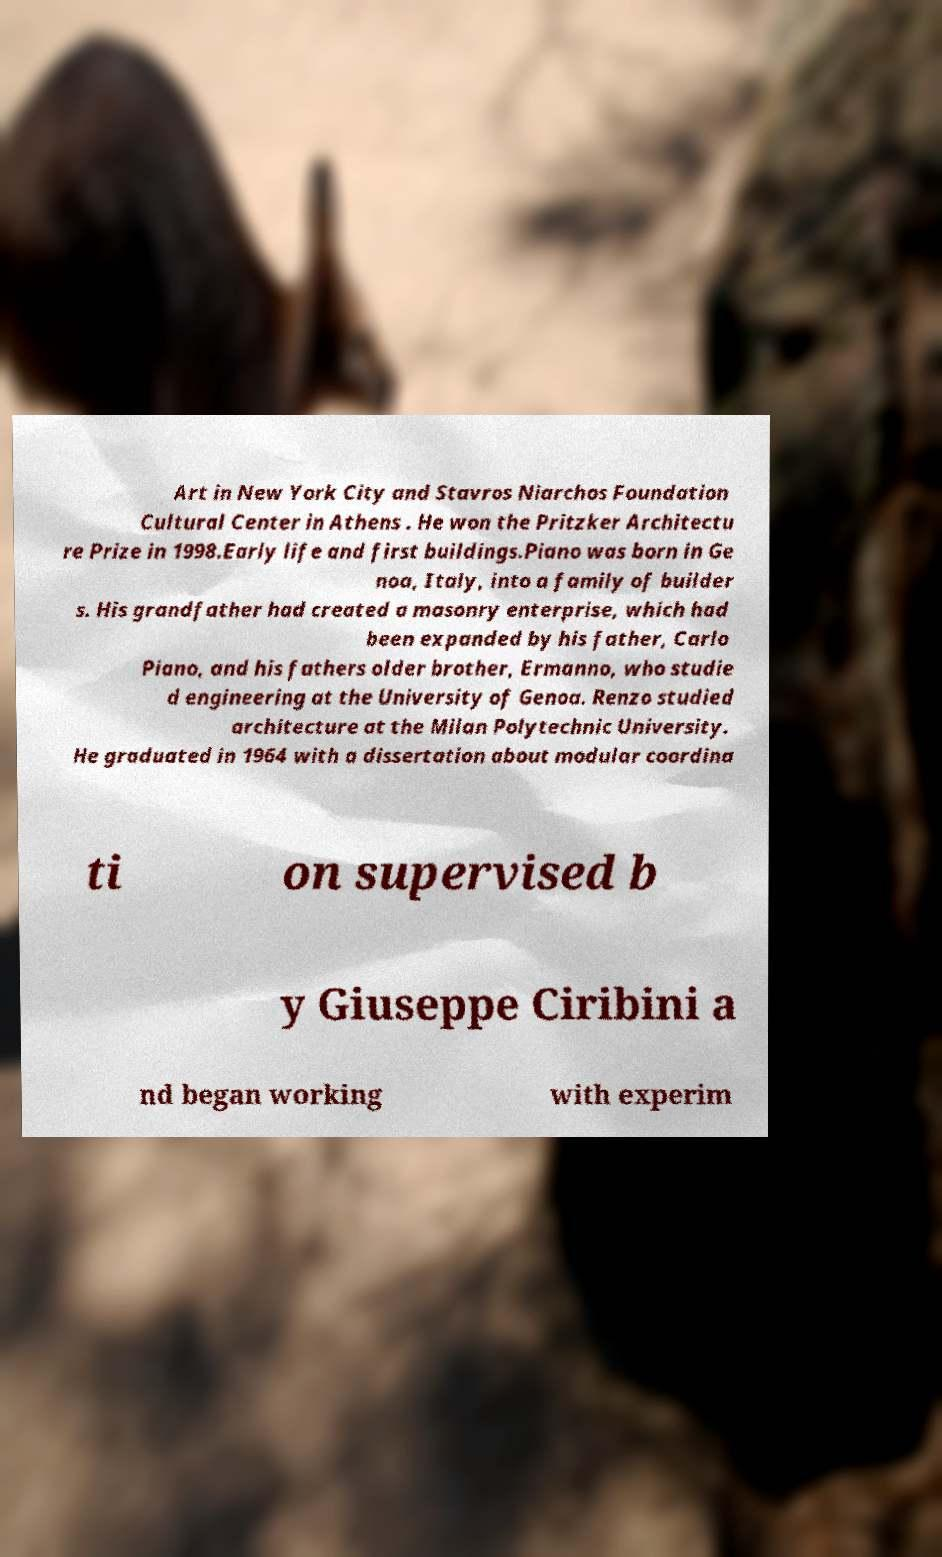Can you read and provide the text displayed in the image?This photo seems to have some interesting text. Can you extract and type it out for me? Art in New York City and Stavros Niarchos Foundation Cultural Center in Athens . He won the Pritzker Architectu re Prize in 1998.Early life and first buildings.Piano was born in Ge noa, Italy, into a family of builder s. His grandfather had created a masonry enterprise, which had been expanded by his father, Carlo Piano, and his fathers older brother, Ermanno, who studie d engineering at the University of Genoa. Renzo studied architecture at the Milan Polytechnic University. He graduated in 1964 with a dissertation about modular coordina ti on supervised b y Giuseppe Ciribini a nd began working with experim 